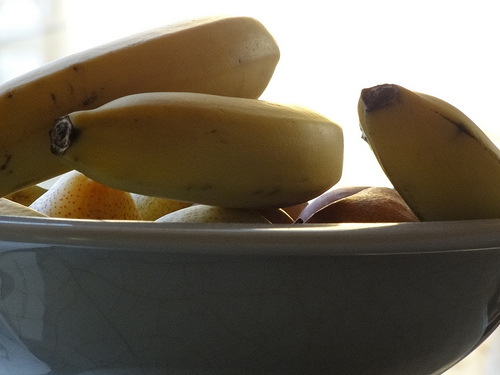<image>
Is there a banana next to the bowl? No. The banana is not positioned next to the bowl. They are located in different areas of the scene. 